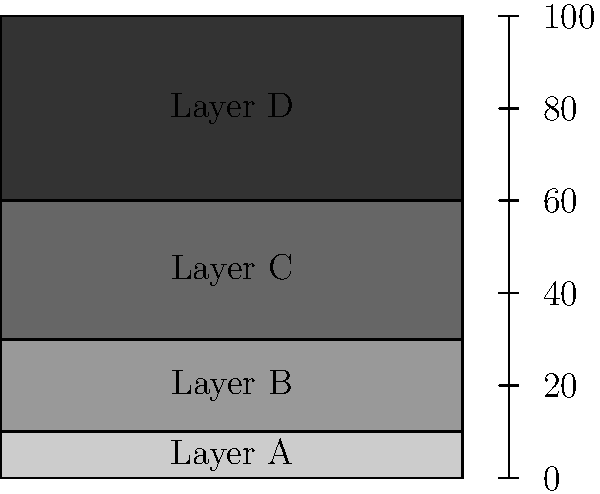In the sedimentary rock formation shown, which layer is likely to be the oldest, and why is this conclusion consistent with the principle of superposition in geology? To answer this question, we need to consider the principle of superposition and analyze the given sedimentary rock formation:

1. The principle of superposition states that in undisturbed sedimentary rock formations, the oldest layers are at the bottom, and the youngest layers are at the top.

2. This principle is based on the understanding that sediments are deposited over time, with newer layers forming on top of older ones.

3. In the given diagram, we can see four distinct layers labeled A, B, C, and D, from bottom to top.

4. Layer A is at the bottom of the formation, between 0 and 10 meters deep.

5. Following the principle of superposition, Layer A would be the oldest layer in this formation.

6. This conclusion is consistent with the principle because:
   a) It assumes the layers have not been significantly disturbed or overturned by geological processes.
   b) Each subsequent layer (B, C, and D) would have been deposited on top of the previous one over time.

7. The relative ages of the layers would be, from oldest to youngest: A, B, C, D.

This analysis demonstrates how geologists use the principle of superposition to determine the relative ages of rock layers in sedimentary formations, contributing to our understanding of geological history without disturbing the natural environment.
Answer: Layer A; it's the bottommost layer in an undisturbed sedimentary formation. 